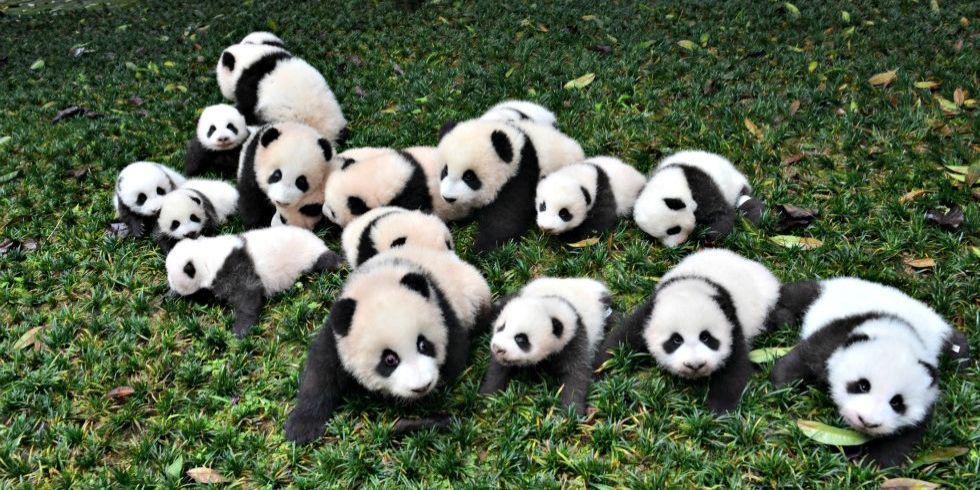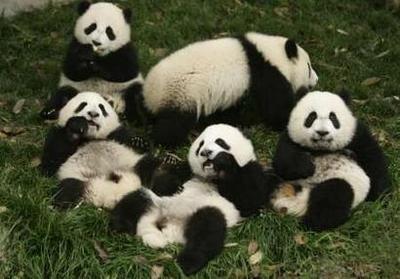The first image is the image on the left, the second image is the image on the right. For the images shown, is this caption "there is at least one panda in a tree in the image pair" true? Answer yes or no. No. The first image is the image on the left, the second image is the image on the right. For the images shown, is this caption "At least one panda is in a tree." true? Answer yes or no. No. 